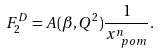Convert formula to latex. <formula><loc_0><loc_0><loc_500><loc_500>F _ { 2 } ^ { D } = A ( \beta , Q ^ { 2 } ) \frac { 1 } { x _ { \ p o m } ^ { n } } .</formula> 